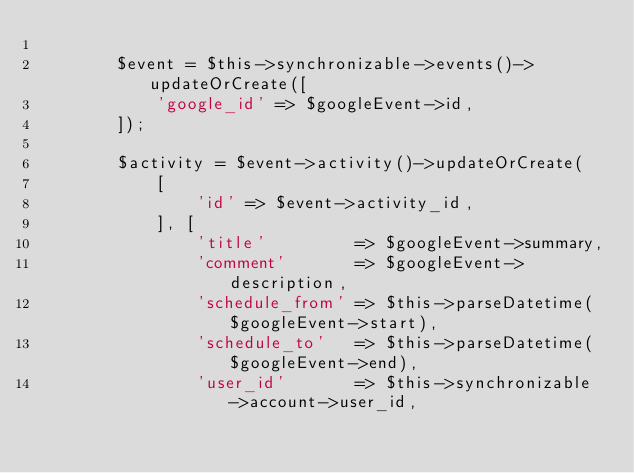<code> <loc_0><loc_0><loc_500><loc_500><_PHP_>
        $event = $this->synchronizable->events()->updateOrCreate([
            'google_id' => $googleEvent->id,
        ]);

        $activity = $event->activity()->updateOrCreate(
            [
                'id' => $event->activity_id,
            ], [
                'title'         => $googleEvent->summary,
                'comment'       => $googleEvent->description,
                'schedule_from' => $this->parseDatetime($googleEvent->start),
                'schedule_to'   => $this->parseDatetime($googleEvent->end),
                'user_id'       => $this->synchronizable->account->user_id,</code> 